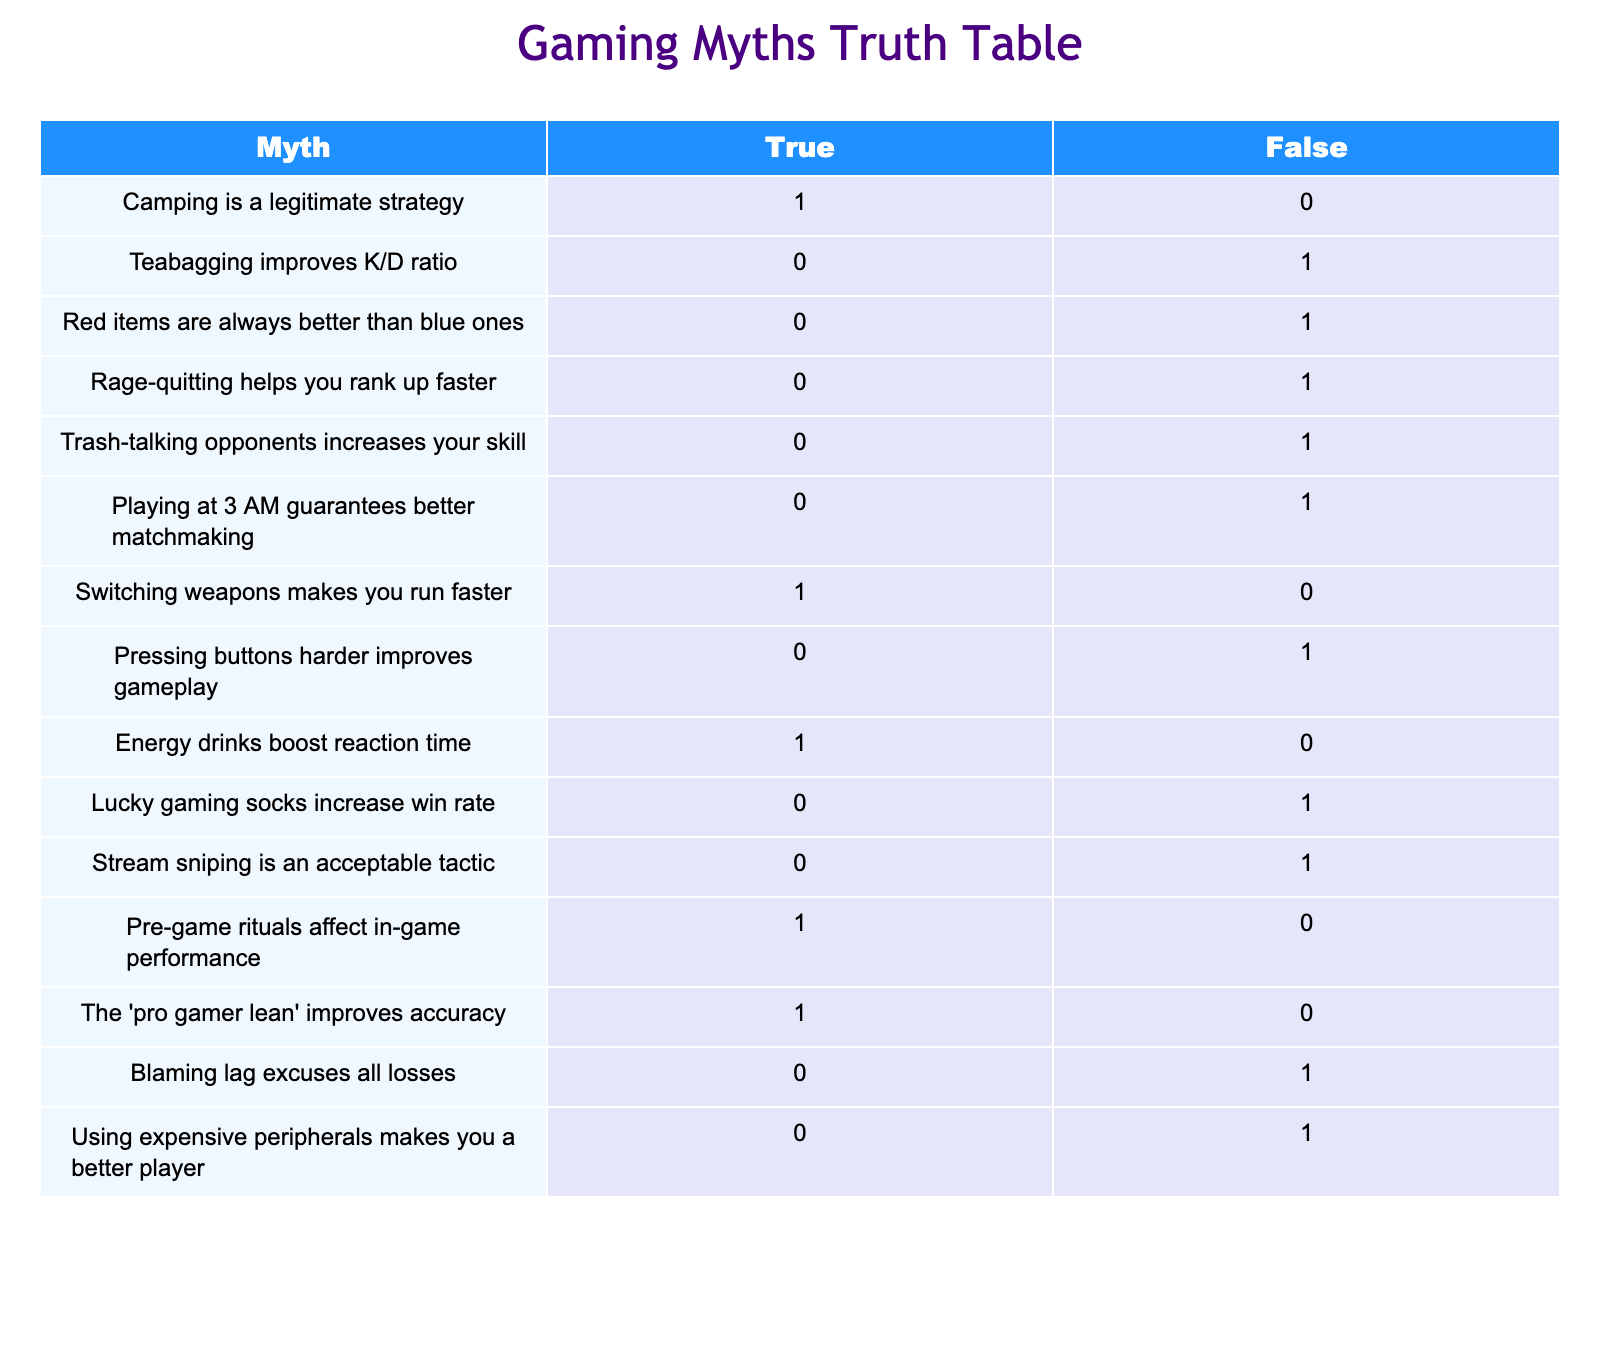What is the truth value of the myth "Camping is a legitimate strategy"? The table shows that the myth "Camping is a legitimate strategy" has a truth value of 1 (True).
Answer: True How many myths are considered false in the table? By counting the number of myths that have a value of 0 (False), we find 9 myths are marked as false.
Answer: 9 Is it true or false that "Teabagging improves K/D ratio"? Looking at the table, "Teabagging improves K/D ratio" is listed with a truth value of 0 (False).
Answer: False What is the total number of myths that are true? From the table, we see 5 myths have a truth value of 1 (True), indicating they are considered true.
Answer: 5 Which myth has the same truth value as "The 'pro gamer lean' improves accuracy"? "The 'pro gamer lean' improves accuracy" is true (1) and shares this truth value with "Switching weapons makes you run faster" and "Pre-game rituals affect in-game performance."
Answer: "Switching weapons" and "Pre-game rituals" Does "Blaming lag excuses all losses" have a truth value of true or false? The myth "Blaming lag excuses all losses" is on the table with a value of 0 (False), meaning it is considered false.
Answer: False If we consider only the items marked true, how many relate to player behavior versus equipment? The truths related to player behavior are "Camping is a legitimate strategy," "Switching weapons makes you run faster," "Energy drinks boost reaction time," "Pre-game rituals affect in-game performance," and "The 'pro gamer lean' improves accuracy," giving us 5 myths. The only equipment applicable here pertains to "Energy drinks" and "The 'pro gamer lean'" (2). So 5 out of 5 truth items relate to player behavior.
Answer: 5 Player Behavior, 0 Equipment Among the myths listed, which one specifically states that peripheral quality affects player ability? The myth about peripheral quality is "Using expensive peripherals makes you a better player," which is indicated as false in the table.
Answer: False Is there a myth that suggests a correlation between time of day and matchmaking? Yes, the myth "Playing at 3 AM guarantees better matchmaking" suggests such a correlation, and it is false according to the table.
Answer: Yes, it's false 